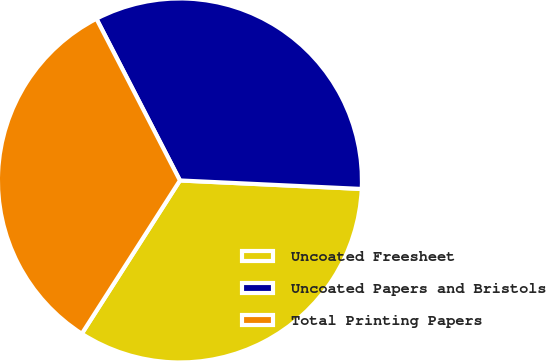Convert chart to OTSL. <chart><loc_0><loc_0><loc_500><loc_500><pie_chart><fcel>Uncoated Freesheet<fcel>Uncoated Papers and Bristols<fcel>Total Printing Papers<nl><fcel>33.32%<fcel>33.33%<fcel>33.35%<nl></chart> 